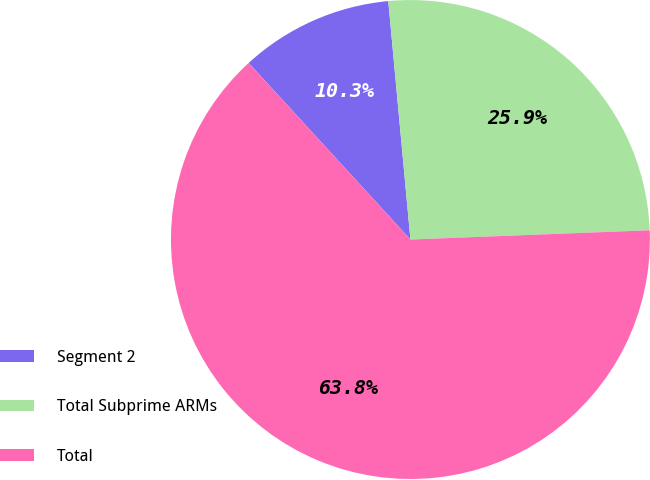<chart> <loc_0><loc_0><loc_500><loc_500><pie_chart><fcel>Segment 2<fcel>Total Subprime ARMs<fcel>Total<nl><fcel>10.33%<fcel>25.86%<fcel>63.81%<nl></chart> 